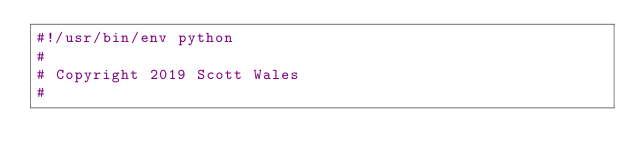Convert code to text. <code><loc_0><loc_0><loc_500><loc_500><_Python_>#!/usr/bin/env python
#
# Copyright 2019 Scott Wales
#</code> 